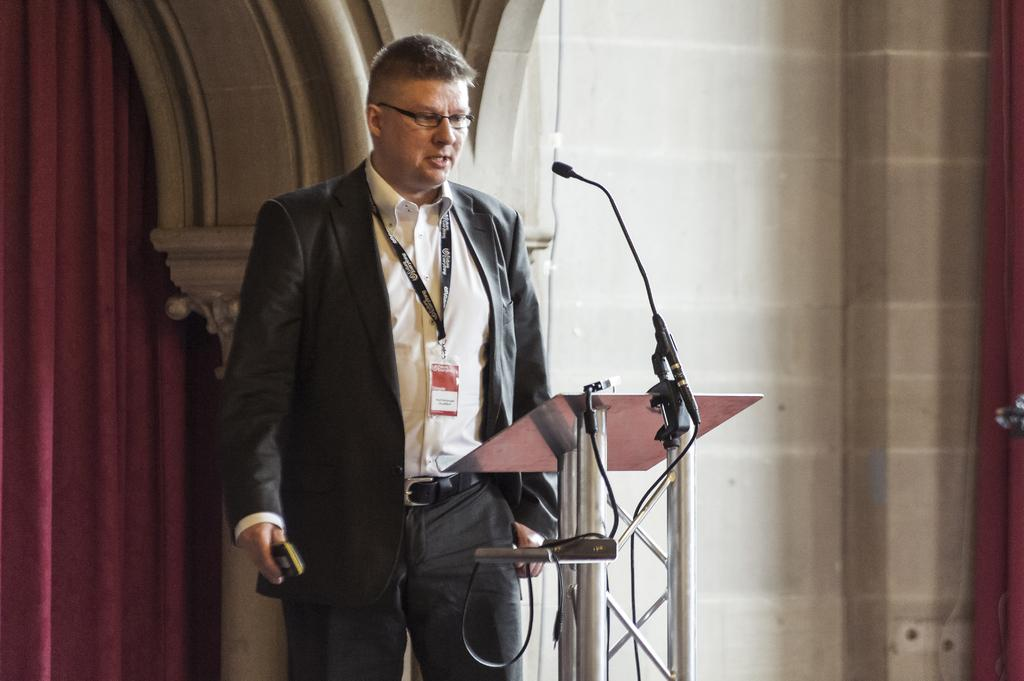Who is in the image? There is a man in the image. What is the man wearing? The man is wearing a black suit. What is the man standing in front of? The man is standing in front of a metal pipe speech desk. What can be seen in the background of the image? There is a brick wall and a red curtain in the background of the image. What type of juice is the man holding in the image? There is no juice present in the image; the man is standing in front of a metal pipe speech desk. 